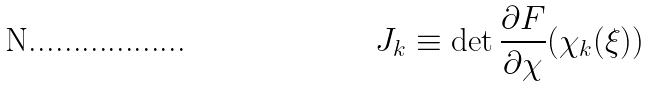Convert formula to latex. <formula><loc_0><loc_0><loc_500><loc_500>J _ { k } \equiv \det \frac { \partial F } { \partial \chi } ( \chi _ { k } ( \xi ) )</formula> 